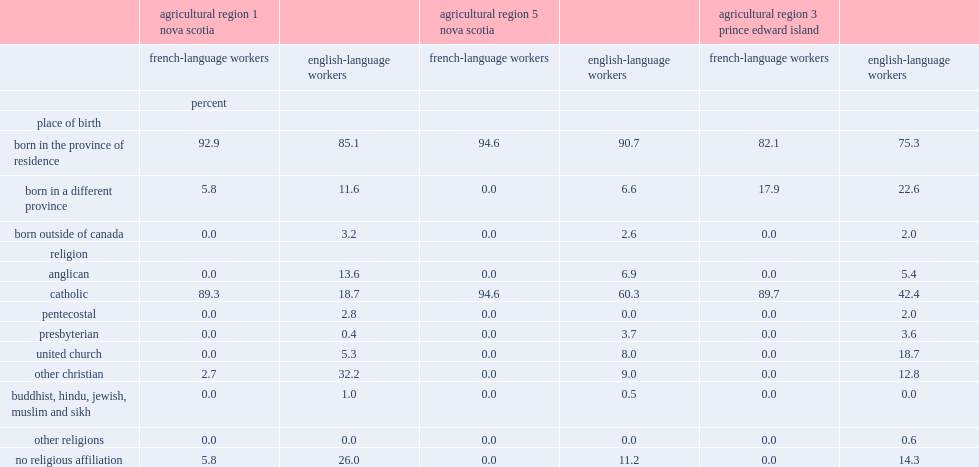Which sector of workers was less likely to be born in another province or country? french-language workers or english-language workers? French-language workers. Which sector of workers was more likely to be a catholic? french-language workers or english-language workers? French-language workers. Which religion is the most popular religion among the french-language workers in the agri-food sector? Catholic. Which sector of workers was less likely to have no religious affiliation? french-language workers or english-language workers? French-language workers. 